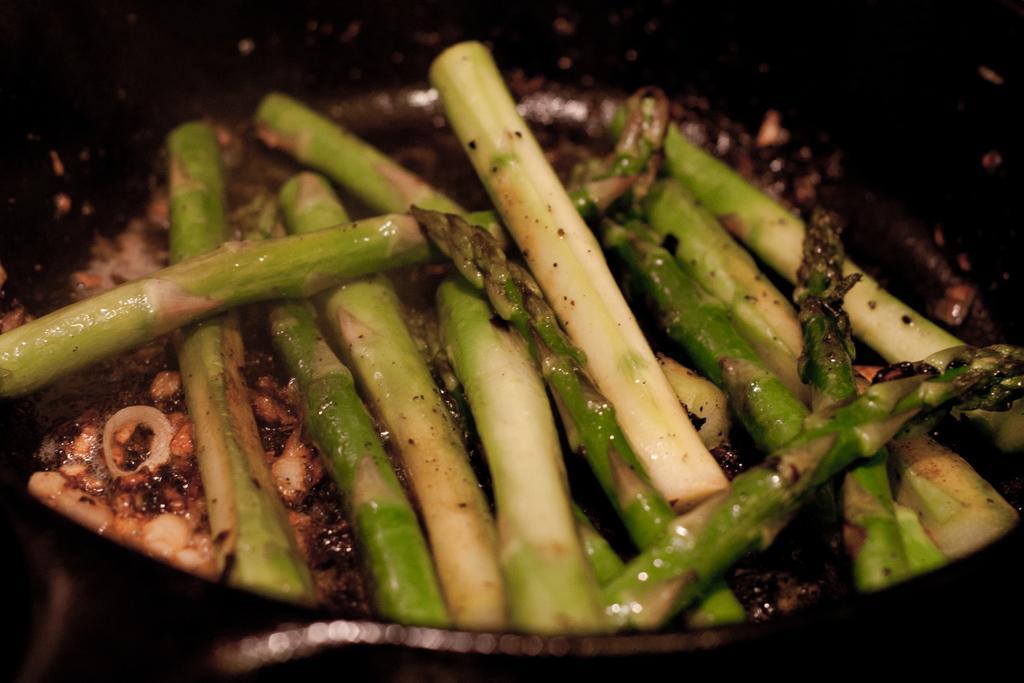Can you describe this image briefly? In this image we can see some food in the pan and the background is dark. 